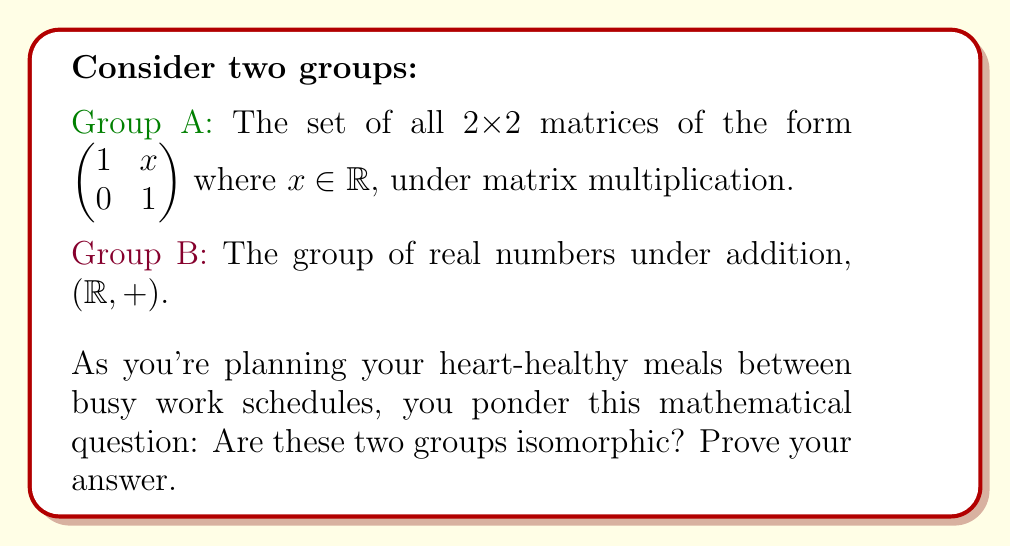Teach me how to tackle this problem. Let's approach this step-by-step:

1) First, let's define a mapping $f$ from Group A to Group B:
   $f: \begin{pmatrix} 1 & x \\ 0 & 1 \end{pmatrix} \mapsto x$

2) We need to prove that this mapping is bijective and preserves the group operation.

3) Bijective:
   - Injective: Different matrices in A map to different real numbers in B.
   - Surjective: Every real number in B has a corresponding matrix in A.

4) Preserves group operation:
   Let's take two elements from A: $\begin{pmatrix} 1 & a \\ 0 & 1 \end{pmatrix}$ and $\begin{pmatrix} 1 & b \\ 0 & 1 \end{pmatrix}$
   
   Their product in A is:
   $$\begin{pmatrix} 1 & a \\ 0 & 1 \end{pmatrix} \cdot \begin{pmatrix} 1 & b \\ 0 & 1 \end{pmatrix} = \begin{pmatrix} 1 & a+b \\ 0 & 1 \end{pmatrix}$$

   $f$ of this product is $a+b$

   On the other hand, $f(\begin{pmatrix} 1 & a \\ 0 & 1 \end{pmatrix}) + f(\begin{pmatrix} 1 & b \\ 0 & 1 \end{pmatrix}) = a + b$

5) Therefore, $f(xy) = f(x) + f(y)$ for all $x, y$ in A, where $xy$ denotes matrix multiplication in A and $+$ denotes addition in B.

6) Thus, $f$ is an isomorphism between A and B.

This proof shows that while you're planning your heart-healthy meals, you can think of these matrices as just real numbers under addition, simplifying your mathematical ponderings!
Answer: Yes, the groups are isomorphic. 